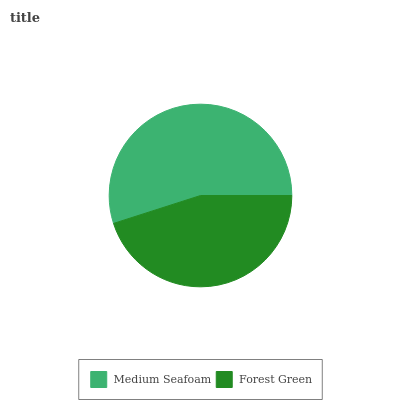Is Forest Green the minimum?
Answer yes or no. Yes. Is Medium Seafoam the maximum?
Answer yes or no. Yes. Is Forest Green the maximum?
Answer yes or no. No. Is Medium Seafoam greater than Forest Green?
Answer yes or no. Yes. Is Forest Green less than Medium Seafoam?
Answer yes or no. Yes. Is Forest Green greater than Medium Seafoam?
Answer yes or no. No. Is Medium Seafoam less than Forest Green?
Answer yes or no. No. Is Medium Seafoam the high median?
Answer yes or no. Yes. Is Forest Green the low median?
Answer yes or no. Yes. Is Forest Green the high median?
Answer yes or no. No. Is Medium Seafoam the low median?
Answer yes or no. No. 